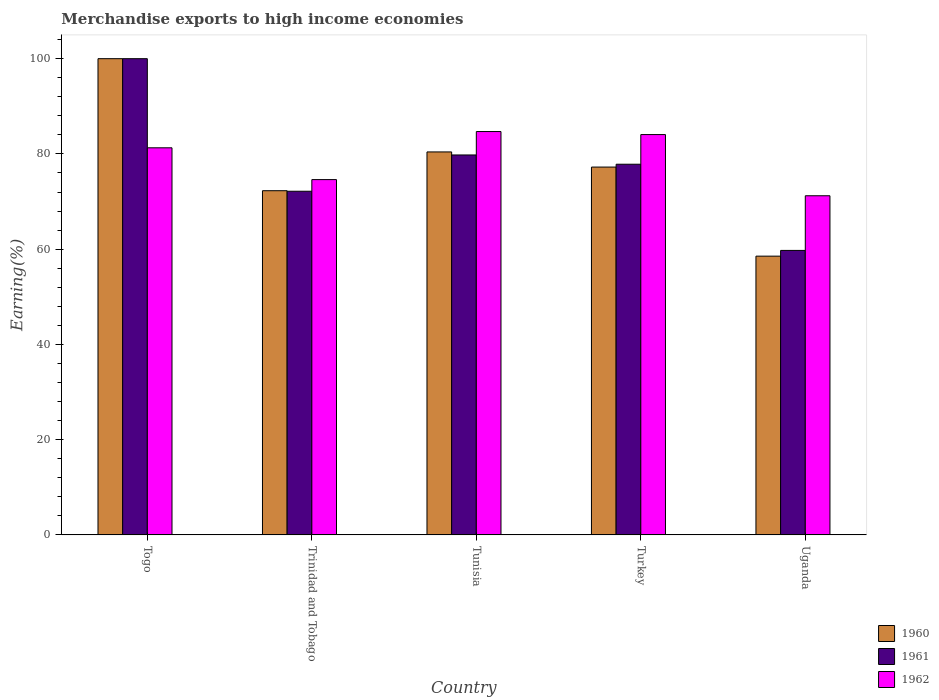How many different coloured bars are there?
Provide a short and direct response. 3. How many groups of bars are there?
Your response must be concise. 5. Are the number of bars on each tick of the X-axis equal?
Offer a terse response. Yes. How many bars are there on the 4th tick from the left?
Make the answer very short. 3. How many bars are there on the 2nd tick from the right?
Provide a short and direct response. 3. What is the label of the 4th group of bars from the left?
Keep it short and to the point. Turkey. In how many cases, is the number of bars for a given country not equal to the number of legend labels?
Provide a short and direct response. 0. What is the percentage of amount earned from merchandise exports in 1960 in Trinidad and Tobago?
Provide a succinct answer. 72.27. Across all countries, what is the maximum percentage of amount earned from merchandise exports in 1962?
Your answer should be very brief. 84.7. Across all countries, what is the minimum percentage of amount earned from merchandise exports in 1960?
Provide a short and direct response. 58.53. In which country was the percentage of amount earned from merchandise exports in 1960 maximum?
Keep it short and to the point. Togo. In which country was the percentage of amount earned from merchandise exports in 1961 minimum?
Keep it short and to the point. Uganda. What is the total percentage of amount earned from merchandise exports in 1961 in the graph?
Offer a terse response. 389.52. What is the difference between the percentage of amount earned from merchandise exports in 1961 in Trinidad and Tobago and that in Turkey?
Offer a very short reply. -5.68. What is the difference between the percentage of amount earned from merchandise exports in 1960 in Trinidad and Tobago and the percentage of amount earned from merchandise exports in 1962 in Uganda?
Offer a very short reply. 1.06. What is the average percentage of amount earned from merchandise exports in 1961 per country?
Offer a terse response. 77.9. What is the difference between the percentage of amount earned from merchandise exports of/in 1962 and percentage of amount earned from merchandise exports of/in 1961 in Uganda?
Keep it short and to the point. 11.48. In how many countries, is the percentage of amount earned from merchandise exports in 1962 greater than 80 %?
Provide a succinct answer. 3. What is the ratio of the percentage of amount earned from merchandise exports in 1960 in Togo to that in Turkey?
Your response must be concise. 1.29. Is the percentage of amount earned from merchandise exports in 1962 in Togo less than that in Tunisia?
Your answer should be very brief. Yes. Is the difference between the percentage of amount earned from merchandise exports in 1962 in Togo and Tunisia greater than the difference between the percentage of amount earned from merchandise exports in 1961 in Togo and Tunisia?
Provide a short and direct response. No. What is the difference between the highest and the second highest percentage of amount earned from merchandise exports in 1962?
Give a very brief answer. -3.42. What is the difference between the highest and the lowest percentage of amount earned from merchandise exports in 1961?
Make the answer very short. 40.26. Is it the case that in every country, the sum of the percentage of amount earned from merchandise exports in 1960 and percentage of amount earned from merchandise exports in 1962 is greater than the percentage of amount earned from merchandise exports in 1961?
Make the answer very short. Yes. Are all the bars in the graph horizontal?
Offer a terse response. No. How many countries are there in the graph?
Offer a terse response. 5. What is the difference between two consecutive major ticks on the Y-axis?
Give a very brief answer. 20. Are the values on the major ticks of Y-axis written in scientific E-notation?
Provide a succinct answer. No. Does the graph contain grids?
Keep it short and to the point. No. Where does the legend appear in the graph?
Provide a short and direct response. Bottom right. How are the legend labels stacked?
Ensure brevity in your answer.  Vertical. What is the title of the graph?
Give a very brief answer. Merchandise exports to high income economies. What is the label or title of the X-axis?
Your answer should be compact. Country. What is the label or title of the Y-axis?
Your answer should be compact. Earning(%). What is the Earning(%) in 1960 in Togo?
Give a very brief answer. 100. What is the Earning(%) of 1962 in Togo?
Keep it short and to the point. 81.29. What is the Earning(%) of 1960 in Trinidad and Tobago?
Ensure brevity in your answer.  72.27. What is the Earning(%) of 1961 in Trinidad and Tobago?
Ensure brevity in your answer.  72.16. What is the Earning(%) in 1962 in Trinidad and Tobago?
Ensure brevity in your answer.  74.61. What is the Earning(%) in 1960 in Tunisia?
Make the answer very short. 80.42. What is the Earning(%) of 1961 in Tunisia?
Keep it short and to the point. 79.78. What is the Earning(%) in 1962 in Tunisia?
Offer a terse response. 84.7. What is the Earning(%) of 1960 in Turkey?
Make the answer very short. 77.24. What is the Earning(%) in 1961 in Turkey?
Provide a short and direct response. 77.84. What is the Earning(%) of 1962 in Turkey?
Your answer should be very brief. 84.06. What is the Earning(%) in 1960 in Uganda?
Your answer should be very brief. 58.53. What is the Earning(%) in 1961 in Uganda?
Your answer should be compact. 59.74. What is the Earning(%) of 1962 in Uganda?
Your answer should be very brief. 71.21. Across all countries, what is the maximum Earning(%) of 1960?
Provide a short and direct response. 100. Across all countries, what is the maximum Earning(%) of 1961?
Your response must be concise. 100. Across all countries, what is the maximum Earning(%) of 1962?
Your answer should be compact. 84.7. Across all countries, what is the minimum Earning(%) of 1960?
Keep it short and to the point. 58.53. Across all countries, what is the minimum Earning(%) of 1961?
Make the answer very short. 59.74. Across all countries, what is the minimum Earning(%) of 1962?
Your answer should be compact. 71.21. What is the total Earning(%) of 1960 in the graph?
Your answer should be compact. 388.47. What is the total Earning(%) in 1961 in the graph?
Your answer should be compact. 389.52. What is the total Earning(%) in 1962 in the graph?
Offer a very short reply. 395.88. What is the difference between the Earning(%) of 1960 in Togo and that in Trinidad and Tobago?
Your response must be concise. 27.73. What is the difference between the Earning(%) in 1961 in Togo and that in Trinidad and Tobago?
Ensure brevity in your answer.  27.84. What is the difference between the Earning(%) of 1962 in Togo and that in Trinidad and Tobago?
Your response must be concise. 6.68. What is the difference between the Earning(%) in 1960 in Togo and that in Tunisia?
Provide a succinct answer. 19.58. What is the difference between the Earning(%) of 1961 in Togo and that in Tunisia?
Your response must be concise. 20.22. What is the difference between the Earning(%) of 1962 in Togo and that in Tunisia?
Your answer should be very brief. -3.42. What is the difference between the Earning(%) of 1960 in Togo and that in Turkey?
Your answer should be very brief. 22.76. What is the difference between the Earning(%) in 1961 in Togo and that in Turkey?
Offer a terse response. 22.16. What is the difference between the Earning(%) of 1962 in Togo and that in Turkey?
Your answer should be compact. -2.78. What is the difference between the Earning(%) of 1960 in Togo and that in Uganda?
Your answer should be very brief. 41.47. What is the difference between the Earning(%) of 1961 in Togo and that in Uganda?
Your answer should be very brief. 40.26. What is the difference between the Earning(%) of 1962 in Togo and that in Uganda?
Offer a very short reply. 10.07. What is the difference between the Earning(%) in 1960 in Trinidad and Tobago and that in Tunisia?
Offer a very short reply. -8.14. What is the difference between the Earning(%) in 1961 in Trinidad and Tobago and that in Tunisia?
Ensure brevity in your answer.  -7.62. What is the difference between the Earning(%) in 1962 in Trinidad and Tobago and that in Tunisia?
Your answer should be very brief. -10.09. What is the difference between the Earning(%) in 1960 in Trinidad and Tobago and that in Turkey?
Provide a succinct answer. -4.97. What is the difference between the Earning(%) of 1961 in Trinidad and Tobago and that in Turkey?
Make the answer very short. -5.68. What is the difference between the Earning(%) in 1962 in Trinidad and Tobago and that in Turkey?
Provide a short and direct response. -9.45. What is the difference between the Earning(%) in 1960 in Trinidad and Tobago and that in Uganda?
Provide a short and direct response. 13.74. What is the difference between the Earning(%) of 1961 in Trinidad and Tobago and that in Uganda?
Make the answer very short. 12.42. What is the difference between the Earning(%) in 1962 in Trinidad and Tobago and that in Uganda?
Provide a short and direct response. 3.39. What is the difference between the Earning(%) in 1960 in Tunisia and that in Turkey?
Offer a very short reply. 3.18. What is the difference between the Earning(%) in 1961 in Tunisia and that in Turkey?
Your answer should be very brief. 1.94. What is the difference between the Earning(%) of 1962 in Tunisia and that in Turkey?
Offer a very short reply. 0.64. What is the difference between the Earning(%) of 1960 in Tunisia and that in Uganda?
Make the answer very short. 21.88. What is the difference between the Earning(%) in 1961 in Tunisia and that in Uganda?
Your answer should be compact. 20.04. What is the difference between the Earning(%) of 1962 in Tunisia and that in Uganda?
Offer a very short reply. 13.49. What is the difference between the Earning(%) of 1960 in Turkey and that in Uganda?
Your answer should be compact. 18.71. What is the difference between the Earning(%) of 1961 in Turkey and that in Uganda?
Your answer should be very brief. 18.1. What is the difference between the Earning(%) of 1962 in Turkey and that in Uganda?
Your answer should be compact. 12.85. What is the difference between the Earning(%) in 1960 in Togo and the Earning(%) in 1961 in Trinidad and Tobago?
Offer a terse response. 27.84. What is the difference between the Earning(%) of 1960 in Togo and the Earning(%) of 1962 in Trinidad and Tobago?
Make the answer very short. 25.39. What is the difference between the Earning(%) of 1961 in Togo and the Earning(%) of 1962 in Trinidad and Tobago?
Provide a short and direct response. 25.39. What is the difference between the Earning(%) of 1960 in Togo and the Earning(%) of 1961 in Tunisia?
Offer a very short reply. 20.22. What is the difference between the Earning(%) in 1960 in Togo and the Earning(%) in 1962 in Tunisia?
Provide a short and direct response. 15.3. What is the difference between the Earning(%) of 1961 in Togo and the Earning(%) of 1962 in Tunisia?
Keep it short and to the point. 15.3. What is the difference between the Earning(%) in 1960 in Togo and the Earning(%) in 1961 in Turkey?
Your answer should be very brief. 22.16. What is the difference between the Earning(%) of 1960 in Togo and the Earning(%) of 1962 in Turkey?
Your answer should be very brief. 15.94. What is the difference between the Earning(%) in 1961 in Togo and the Earning(%) in 1962 in Turkey?
Provide a short and direct response. 15.94. What is the difference between the Earning(%) in 1960 in Togo and the Earning(%) in 1961 in Uganda?
Ensure brevity in your answer.  40.26. What is the difference between the Earning(%) of 1960 in Togo and the Earning(%) of 1962 in Uganda?
Offer a terse response. 28.79. What is the difference between the Earning(%) of 1961 in Togo and the Earning(%) of 1962 in Uganda?
Your response must be concise. 28.79. What is the difference between the Earning(%) of 1960 in Trinidad and Tobago and the Earning(%) of 1961 in Tunisia?
Offer a terse response. -7.51. What is the difference between the Earning(%) in 1960 in Trinidad and Tobago and the Earning(%) in 1962 in Tunisia?
Offer a very short reply. -12.43. What is the difference between the Earning(%) of 1961 in Trinidad and Tobago and the Earning(%) of 1962 in Tunisia?
Provide a succinct answer. -12.54. What is the difference between the Earning(%) of 1960 in Trinidad and Tobago and the Earning(%) of 1961 in Turkey?
Ensure brevity in your answer.  -5.56. What is the difference between the Earning(%) in 1960 in Trinidad and Tobago and the Earning(%) in 1962 in Turkey?
Your response must be concise. -11.79. What is the difference between the Earning(%) in 1961 in Trinidad and Tobago and the Earning(%) in 1962 in Turkey?
Provide a succinct answer. -11.9. What is the difference between the Earning(%) of 1960 in Trinidad and Tobago and the Earning(%) of 1961 in Uganda?
Keep it short and to the point. 12.54. What is the difference between the Earning(%) in 1960 in Trinidad and Tobago and the Earning(%) in 1962 in Uganda?
Provide a succinct answer. 1.06. What is the difference between the Earning(%) in 1961 in Trinidad and Tobago and the Earning(%) in 1962 in Uganda?
Give a very brief answer. 0.95. What is the difference between the Earning(%) of 1960 in Tunisia and the Earning(%) of 1961 in Turkey?
Offer a terse response. 2.58. What is the difference between the Earning(%) in 1960 in Tunisia and the Earning(%) in 1962 in Turkey?
Your answer should be compact. -3.65. What is the difference between the Earning(%) in 1961 in Tunisia and the Earning(%) in 1962 in Turkey?
Provide a short and direct response. -4.28. What is the difference between the Earning(%) of 1960 in Tunisia and the Earning(%) of 1961 in Uganda?
Ensure brevity in your answer.  20.68. What is the difference between the Earning(%) of 1960 in Tunisia and the Earning(%) of 1962 in Uganda?
Offer a terse response. 9.2. What is the difference between the Earning(%) of 1961 in Tunisia and the Earning(%) of 1962 in Uganda?
Provide a short and direct response. 8.57. What is the difference between the Earning(%) in 1960 in Turkey and the Earning(%) in 1961 in Uganda?
Your response must be concise. 17.5. What is the difference between the Earning(%) in 1960 in Turkey and the Earning(%) in 1962 in Uganda?
Your answer should be very brief. 6.03. What is the difference between the Earning(%) of 1961 in Turkey and the Earning(%) of 1962 in Uganda?
Provide a short and direct response. 6.62. What is the average Earning(%) of 1960 per country?
Keep it short and to the point. 77.69. What is the average Earning(%) of 1961 per country?
Your response must be concise. 77.9. What is the average Earning(%) of 1962 per country?
Provide a short and direct response. 79.18. What is the difference between the Earning(%) in 1960 and Earning(%) in 1962 in Togo?
Your answer should be very brief. 18.71. What is the difference between the Earning(%) of 1961 and Earning(%) of 1962 in Togo?
Give a very brief answer. 18.71. What is the difference between the Earning(%) in 1960 and Earning(%) in 1961 in Trinidad and Tobago?
Ensure brevity in your answer.  0.11. What is the difference between the Earning(%) of 1960 and Earning(%) of 1962 in Trinidad and Tobago?
Make the answer very short. -2.34. What is the difference between the Earning(%) in 1961 and Earning(%) in 1962 in Trinidad and Tobago?
Make the answer very short. -2.45. What is the difference between the Earning(%) of 1960 and Earning(%) of 1961 in Tunisia?
Give a very brief answer. 0.64. What is the difference between the Earning(%) in 1960 and Earning(%) in 1962 in Tunisia?
Ensure brevity in your answer.  -4.28. What is the difference between the Earning(%) in 1961 and Earning(%) in 1962 in Tunisia?
Provide a short and direct response. -4.92. What is the difference between the Earning(%) in 1960 and Earning(%) in 1961 in Turkey?
Your response must be concise. -0.6. What is the difference between the Earning(%) in 1960 and Earning(%) in 1962 in Turkey?
Ensure brevity in your answer.  -6.82. What is the difference between the Earning(%) of 1961 and Earning(%) of 1962 in Turkey?
Your answer should be very brief. -6.23. What is the difference between the Earning(%) in 1960 and Earning(%) in 1961 in Uganda?
Provide a succinct answer. -1.2. What is the difference between the Earning(%) of 1960 and Earning(%) of 1962 in Uganda?
Your answer should be compact. -12.68. What is the difference between the Earning(%) in 1961 and Earning(%) in 1962 in Uganda?
Make the answer very short. -11.48. What is the ratio of the Earning(%) of 1960 in Togo to that in Trinidad and Tobago?
Provide a short and direct response. 1.38. What is the ratio of the Earning(%) in 1961 in Togo to that in Trinidad and Tobago?
Offer a terse response. 1.39. What is the ratio of the Earning(%) of 1962 in Togo to that in Trinidad and Tobago?
Your response must be concise. 1.09. What is the ratio of the Earning(%) in 1960 in Togo to that in Tunisia?
Offer a very short reply. 1.24. What is the ratio of the Earning(%) in 1961 in Togo to that in Tunisia?
Offer a terse response. 1.25. What is the ratio of the Earning(%) of 1962 in Togo to that in Tunisia?
Ensure brevity in your answer.  0.96. What is the ratio of the Earning(%) of 1960 in Togo to that in Turkey?
Your answer should be compact. 1.29. What is the ratio of the Earning(%) in 1961 in Togo to that in Turkey?
Offer a terse response. 1.28. What is the ratio of the Earning(%) of 1960 in Togo to that in Uganda?
Keep it short and to the point. 1.71. What is the ratio of the Earning(%) of 1961 in Togo to that in Uganda?
Give a very brief answer. 1.67. What is the ratio of the Earning(%) of 1962 in Togo to that in Uganda?
Make the answer very short. 1.14. What is the ratio of the Earning(%) in 1960 in Trinidad and Tobago to that in Tunisia?
Make the answer very short. 0.9. What is the ratio of the Earning(%) of 1961 in Trinidad and Tobago to that in Tunisia?
Offer a terse response. 0.9. What is the ratio of the Earning(%) of 1962 in Trinidad and Tobago to that in Tunisia?
Offer a very short reply. 0.88. What is the ratio of the Earning(%) in 1960 in Trinidad and Tobago to that in Turkey?
Provide a succinct answer. 0.94. What is the ratio of the Earning(%) of 1961 in Trinidad and Tobago to that in Turkey?
Offer a very short reply. 0.93. What is the ratio of the Earning(%) in 1962 in Trinidad and Tobago to that in Turkey?
Ensure brevity in your answer.  0.89. What is the ratio of the Earning(%) in 1960 in Trinidad and Tobago to that in Uganda?
Your response must be concise. 1.23. What is the ratio of the Earning(%) in 1961 in Trinidad and Tobago to that in Uganda?
Your answer should be compact. 1.21. What is the ratio of the Earning(%) of 1962 in Trinidad and Tobago to that in Uganda?
Your answer should be very brief. 1.05. What is the ratio of the Earning(%) of 1960 in Tunisia to that in Turkey?
Your answer should be very brief. 1.04. What is the ratio of the Earning(%) of 1962 in Tunisia to that in Turkey?
Ensure brevity in your answer.  1.01. What is the ratio of the Earning(%) in 1960 in Tunisia to that in Uganda?
Make the answer very short. 1.37. What is the ratio of the Earning(%) in 1961 in Tunisia to that in Uganda?
Keep it short and to the point. 1.34. What is the ratio of the Earning(%) in 1962 in Tunisia to that in Uganda?
Ensure brevity in your answer.  1.19. What is the ratio of the Earning(%) of 1960 in Turkey to that in Uganda?
Your response must be concise. 1.32. What is the ratio of the Earning(%) of 1961 in Turkey to that in Uganda?
Ensure brevity in your answer.  1.3. What is the ratio of the Earning(%) in 1962 in Turkey to that in Uganda?
Ensure brevity in your answer.  1.18. What is the difference between the highest and the second highest Earning(%) of 1960?
Offer a terse response. 19.58. What is the difference between the highest and the second highest Earning(%) in 1961?
Keep it short and to the point. 20.22. What is the difference between the highest and the second highest Earning(%) in 1962?
Give a very brief answer. 0.64. What is the difference between the highest and the lowest Earning(%) in 1960?
Make the answer very short. 41.47. What is the difference between the highest and the lowest Earning(%) in 1961?
Make the answer very short. 40.26. What is the difference between the highest and the lowest Earning(%) of 1962?
Keep it short and to the point. 13.49. 